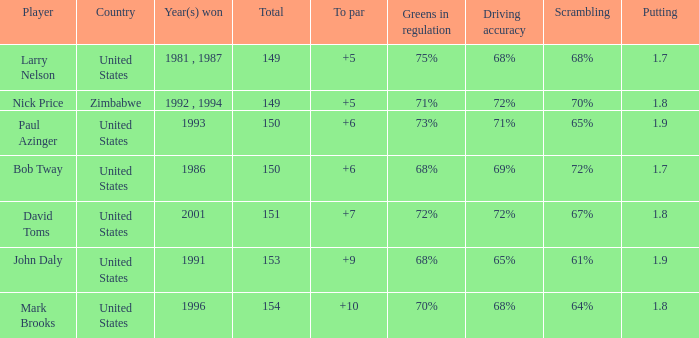What is the total for 1986 with a to par higher than 6? 0.0. Parse the full table. {'header': ['Player', 'Country', 'Year(s) won', 'Total', 'To par', 'Greens in regulation', 'Driving accuracy', 'Scrambling', 'Putting'], 'rows': [['Larry Nelson', 'United States', '1981 , 1987', '149', '+5', '75%', '68%', '68%', '1.7'], ['Nick Price', 'Zimbabwe', '1992 , 1994', '149', '+5', '71%', '72%', '70%', '1.8'], ['Paul Azinger', 'United States', '1993', '150', '+6', '73%', '71%', '65%', '1.9'], ['Bob Tway', 'United States', '1986', '150', '+6', '68%', '69%', '72%', '1.7'], ['David Toms', 'United States', '2001', '151', '+7', '72%', '72%', '67%', '1.8'], ['John Daly', 'United States', '1991', '153', '+9', '68%', '65%', '61%', '1.9'], ['Mark Brooks', 'United States', '1996', '154', '+10', '70%', '68%', '64%', '1.8']]} 